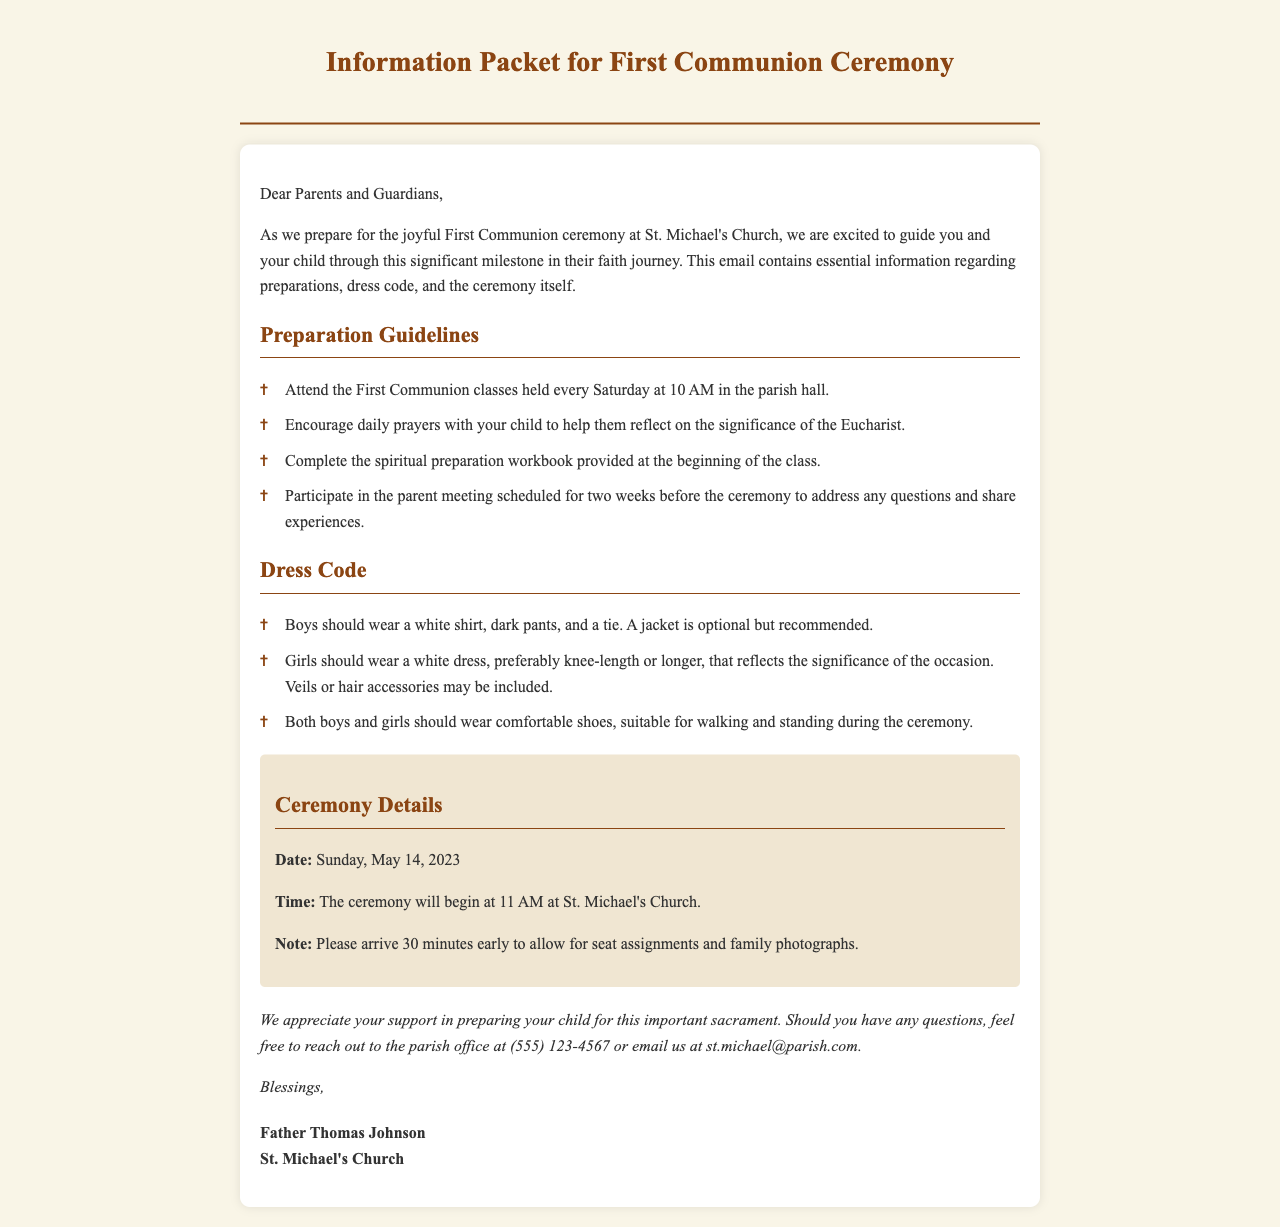What is the date of the First Communion ceremony? The document specifies that the ceremony will take place on Sunday, May 14, 2023.
Answer: May 14, 2023 What time does the ceremony start? According to the document, the ceremony will begin at 11 AM.
Answer: 11 AM What should boys wear for the ceremony? The guidelines indicate that boys should wear a white shirt, dark pants, and a tie.
Answer: White shirt, dark pants, tie What is one of the preparation guidelines? The document mentions several guidelines, one of which is to complete the spiritual preparation workbook.
Answer: Complete the spiritual preparation workbook How early should families arrive before the ceremony? The document notes that families should arrive 30 minutes early to allow for seat assignments and family photographs.
Answer: 30 minutes Which church is hosting the First Communion ceremony? The document states that St. Michael's Church is hosting the ceremony.
Answer: St. Michael's Church Why should parents attend the parent meeting? The document specifies that the parent meeting is to address questions and share experiences related to the ceremony.
Answer: Address questions and share experiences What type of dress is recommended for girls? The information suggests that girls should wear a white dress, preferably knee-length or longer.
Answer: White dress, knee-length or longer What contact information is provided for inquiries? The document includes the parish office's phone number and email for any inquiries.
Answer: (555) 123-4567 or st.michael@parish.com 